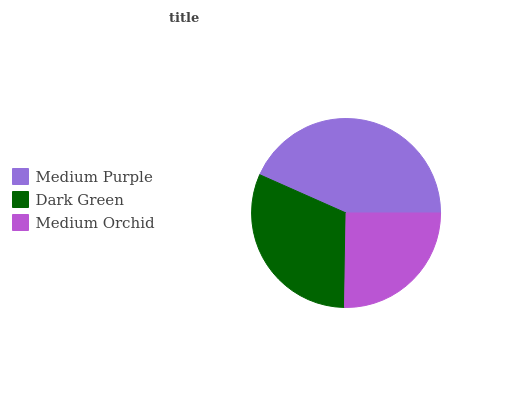Is Medium Orchid the minimum?
Answer yes or no. Yes. Is Medium Purple the maximum?
Answer yes or no. Yes. Is Dark Green the minimum?
Answer yes or no. No. Is Dark Green the maximum?
Answer yes or no. No. Is Medium Purple greater than Dark Green?
Answer yes or no. Yes. Is Dark Green less than Medium Purple?
Answer yes or no. Yes. Is Dark Green greater than Medium Purple?
Answer yes or no. No. Is Medium Purple less than Dark Green?
Answer yes or no. No. Is Dark Green the high median?
Answer yes or no. Yes. Is Dark Green the low median?
Answer yes or no. Yes. Is Medium Purple the high median?
Answer yes or no. No. Is Medium Purple the low median?
Answer yes or no. No. 